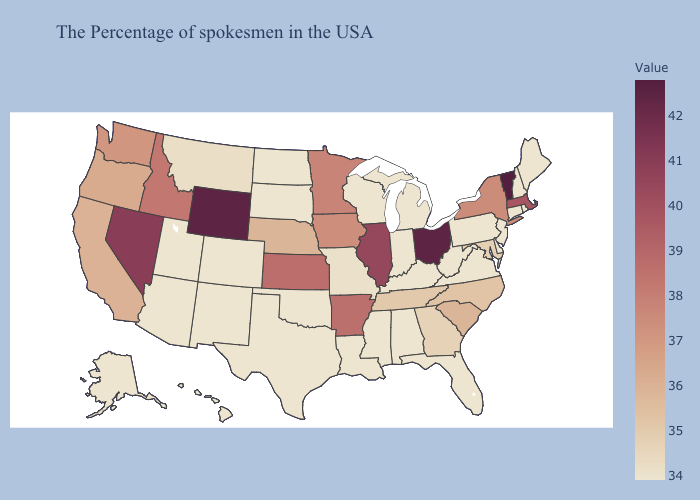Does New York have the lowest value in the USA?
Keep it brief. No. Among the states that border Massachusetts , which have the highest value?
Concise answer only. Vermont. Is the legend a continuous bar?
Keep it brief. Yes. Which states have the highest value in the USA?
Quick response, please. Vermont. Among the states that border Florida , does Georgia have the highest value?
Answer briefly. Yes. 